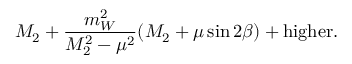<formula> <loc_0><loc_0><loc_500><loc_500>M _ { 2 } + \frac { m _ { W } ^ { 2 } } { M _ { 2 } ^ { 2 } - \mu ^ { 2 } } ( M _ { 2 } + \mu \sin 2 \beta ) + h i g h e r .</formula> 